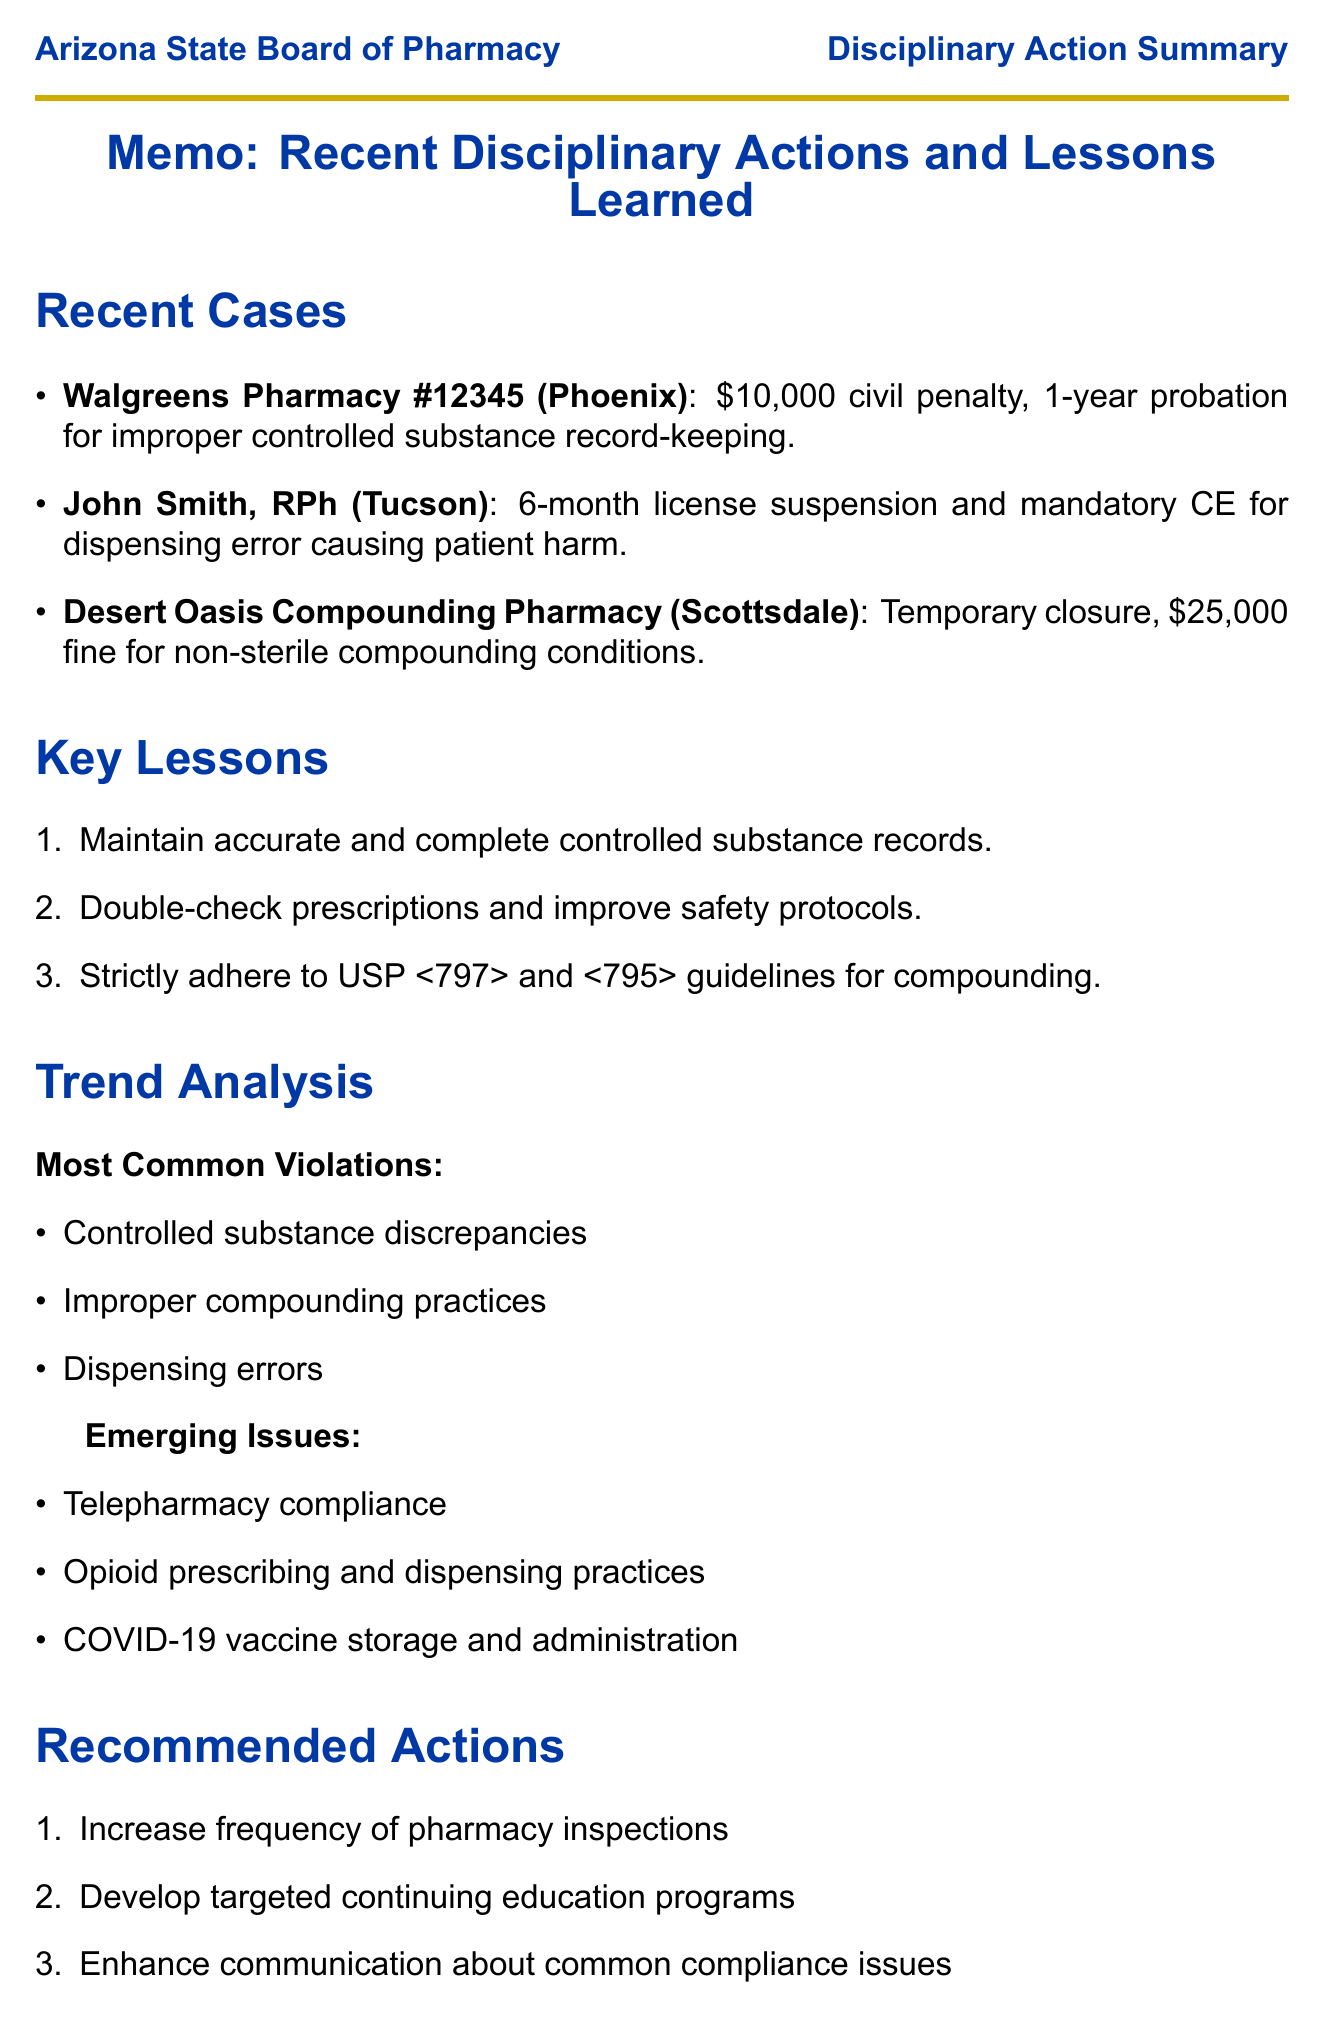what was the penalty for Walgreens Pharmacy #12345? The penalty is specified as a civil penalty and a probation period for the violation described in the document.
Answer: $10,000 and 1-year probation what violation did John Smith, RPh commit? The document outlines the specific violation associated with each case, including John Smith's.
Answer: Dispensing error resulting in patient harm what is the lesson learned from Desert Oasis Compounding Pharmacy's case? Each case is followed by a lesson learned, reflecting on the importance of compliance and standards.
Answer: Strict adherence to USP <797> and <795> guidelines for compounding practices what are the most common violations listed in the trend analysis? The document summarizes common violations based on recent disciplinary actions to highlight areas of concern.
Answer: Controlled substance discrepancies how many months was John Smith's license suspended? The license suspension period is explicitly mentioned in the description of John Smith's case.
Answer: 6 months what is the title of the relevant legislation mentioned in the document? The document cites specific legislation that relates to pharmacy regulations.
Answer: SB 1372 "Pharmacy Board; Regulation" what is one recommended action from the document? Recommendations are listed to address issues identified through disciplinary actions and trends.
Answer: Increase frequency of pharmacy inspections which state has a notable program for disciplined pharmacists? The comparison provides insight into programs available in other states that may offer solutions for issues faced by the Board.
Answer: Texas 